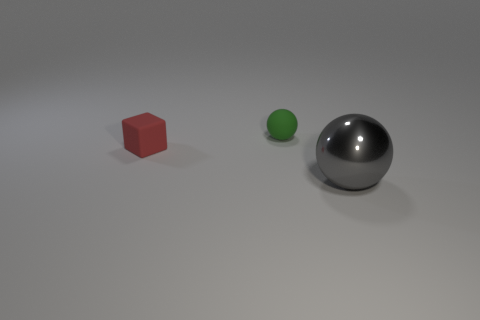Add 3 red objects. How many objects exist? 6 Subtract all blocks. How many objects are left? 2 Subtract all green blocks. Subtract all green objects. How many objects are left? 2 Add 1 green spheres. How many green spheres are left? 2 Add 3 gray metallic spheres. How many gray metallic spheres exist? 4 Subtract 0 green blocks. How many objects are left? 3 